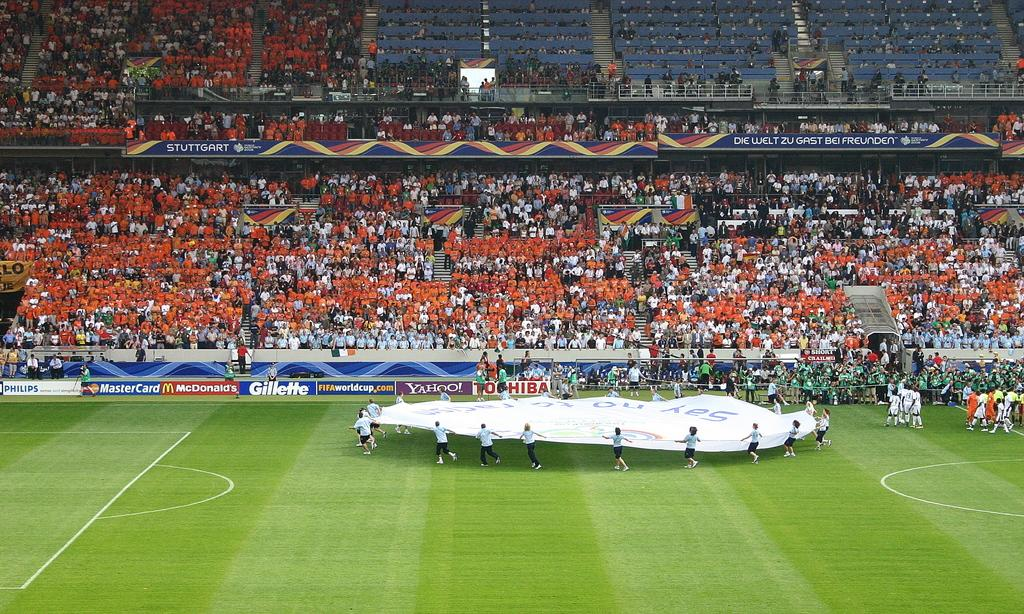<image>
Create a compact narrative representing the image presented. A soccer field with several commercial banners including one for Gillette 